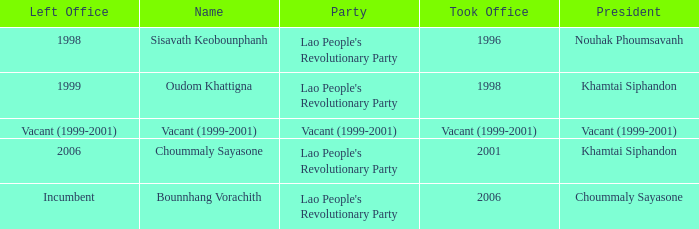What is Name, when President is Khamtai Siphandon, and when Left Office is 1999? Oudom Khattigna. 